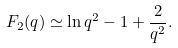<formula> <loc_0><loc_0><loc_500><loc_500>F _ { 2 } ( q ) \simeq \ln q ^ { 2 } - 1 + \frac { 2 } { q ^ { 2 } } .</formula> 